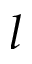Convert formula to latex. <formula><loc_0><loc_0><loc_500><loc_500>l</formula> 